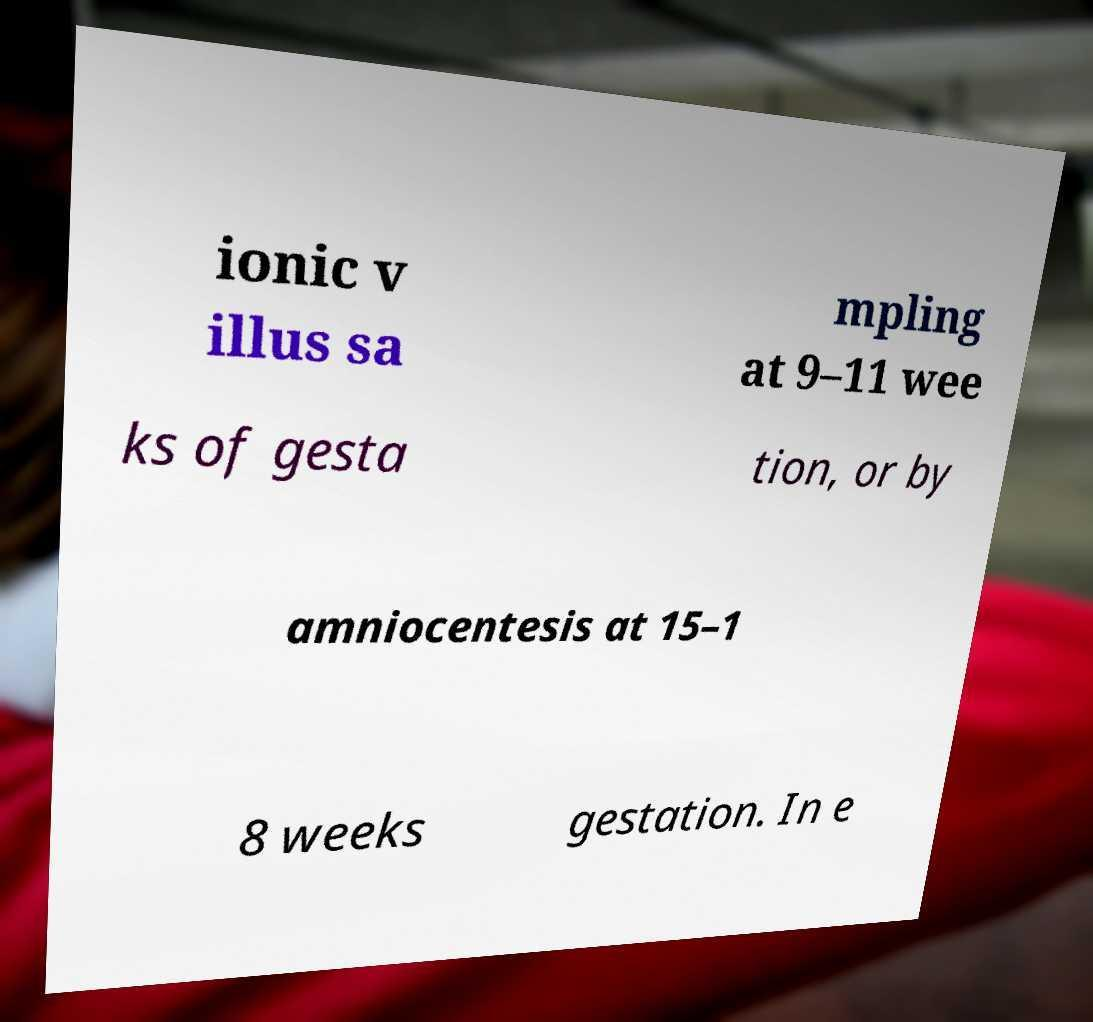For documentation purposes, I need the text within this image transcribed. Could you provide that? ionic v illus sa mpling at 9–11 wee ks of gesta tion, or by amniocentesis at 15–1 8 weeks gestation. In e 